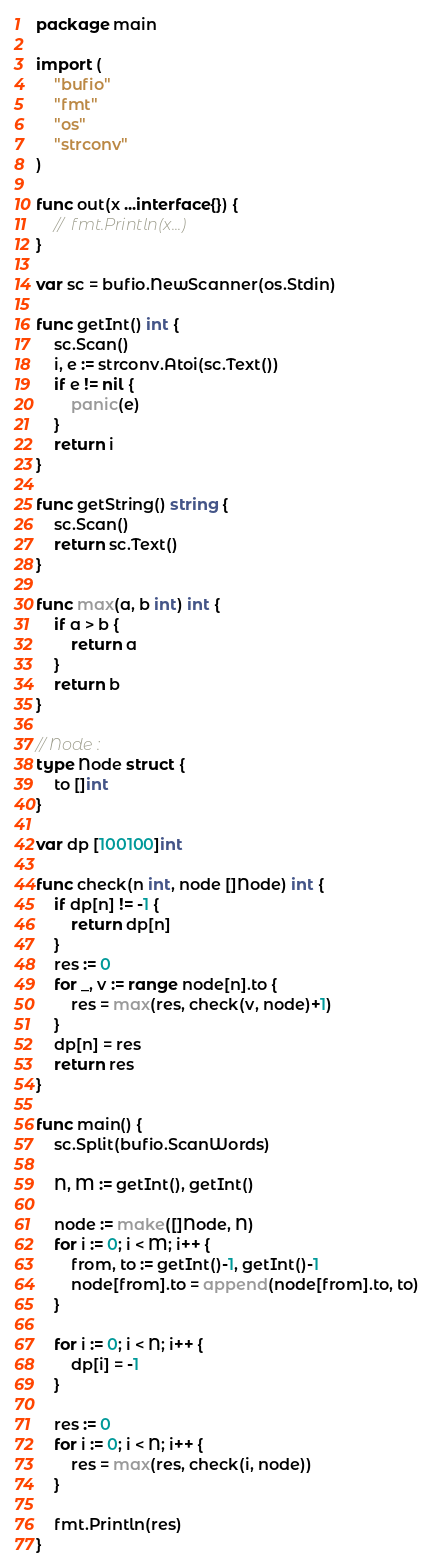<code> <loc_0><loc_0><loc_500><loc_500><_Go_>package main

import (
	"bufio"
	"fmt"
	"os"
	"strconv"
)

func out(x ...interface{}) {
	//	fmt.Println(x...)
}

var sc = bufio.NewScanner(os.Stdin)

func getInt() int {
	sc.Scan()
	i, e := strconv.Atoi(sc.Text())
	if e != nil {
		panic(e)
	}
	return i
}

func getString() string {
	sc.Scan()
	return sc.Text()
}

func max(a, b int) int {
	if a > b {
		return a
	}
	return b
}

// Node :
type Node struct {
	to []int
}

var dp [100100]int

func check(n int, node []Node) int {
	if dp[n] != -1 {
		return dp[n]
	}
	res := 0
	for _, v := range node[n].to {
		res = max(res, check(v, node)+1)
	}
	dp[n] = res
	return res
}

func main() {
	sc.Split(bufio.ScanWords)

	N, M := getInt(), getInt()

	node := make([]Node, N)
	for i := 0; i < M; i++ {
		from, to := getInt()-1, getInt()-1
		node[from].to = append(node[from].to, to)
	}

	for i := 0; i < N; i++ {
		dp[i] = -1
	}

	res := 0
	for i := 0; i < N; i++ {
		res = max(res, check(i, node))
	}

	fmt.Println(res)
}
</code> 